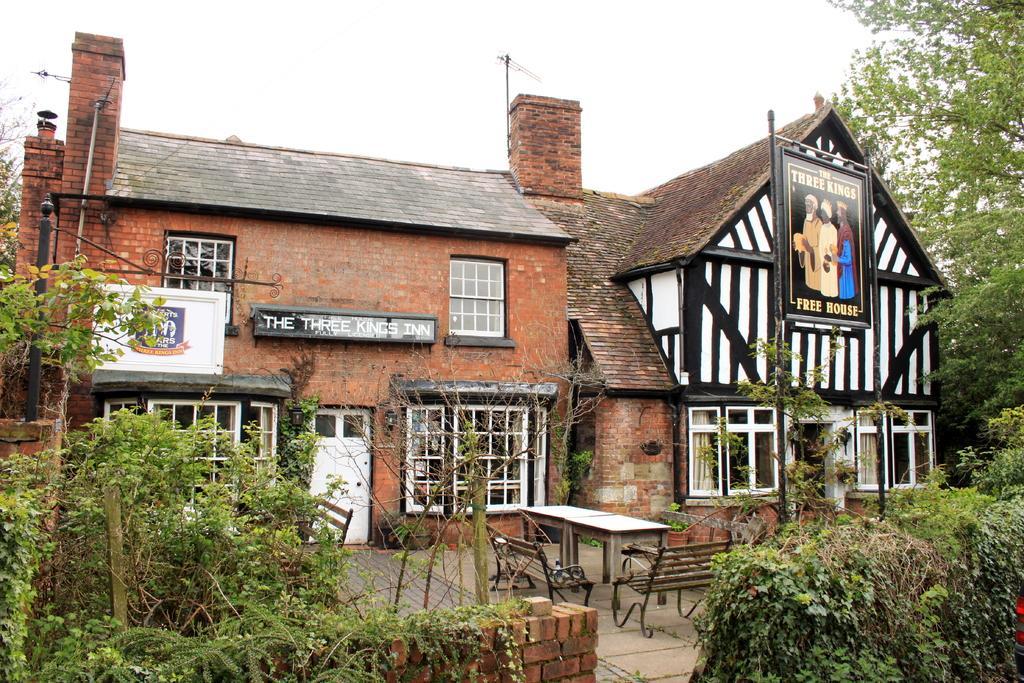Could you give a brief overview of what you see in this image? In this image there is the sky towards the top of the image, there is a building, there is a door, there are windows, there is a pole, there are birds, there are boards on the building, there is text on the board, there is a table, there are benches, there is a brick wall towards the bottom of the image, there are plants, there is a tree towards the right of the image. 